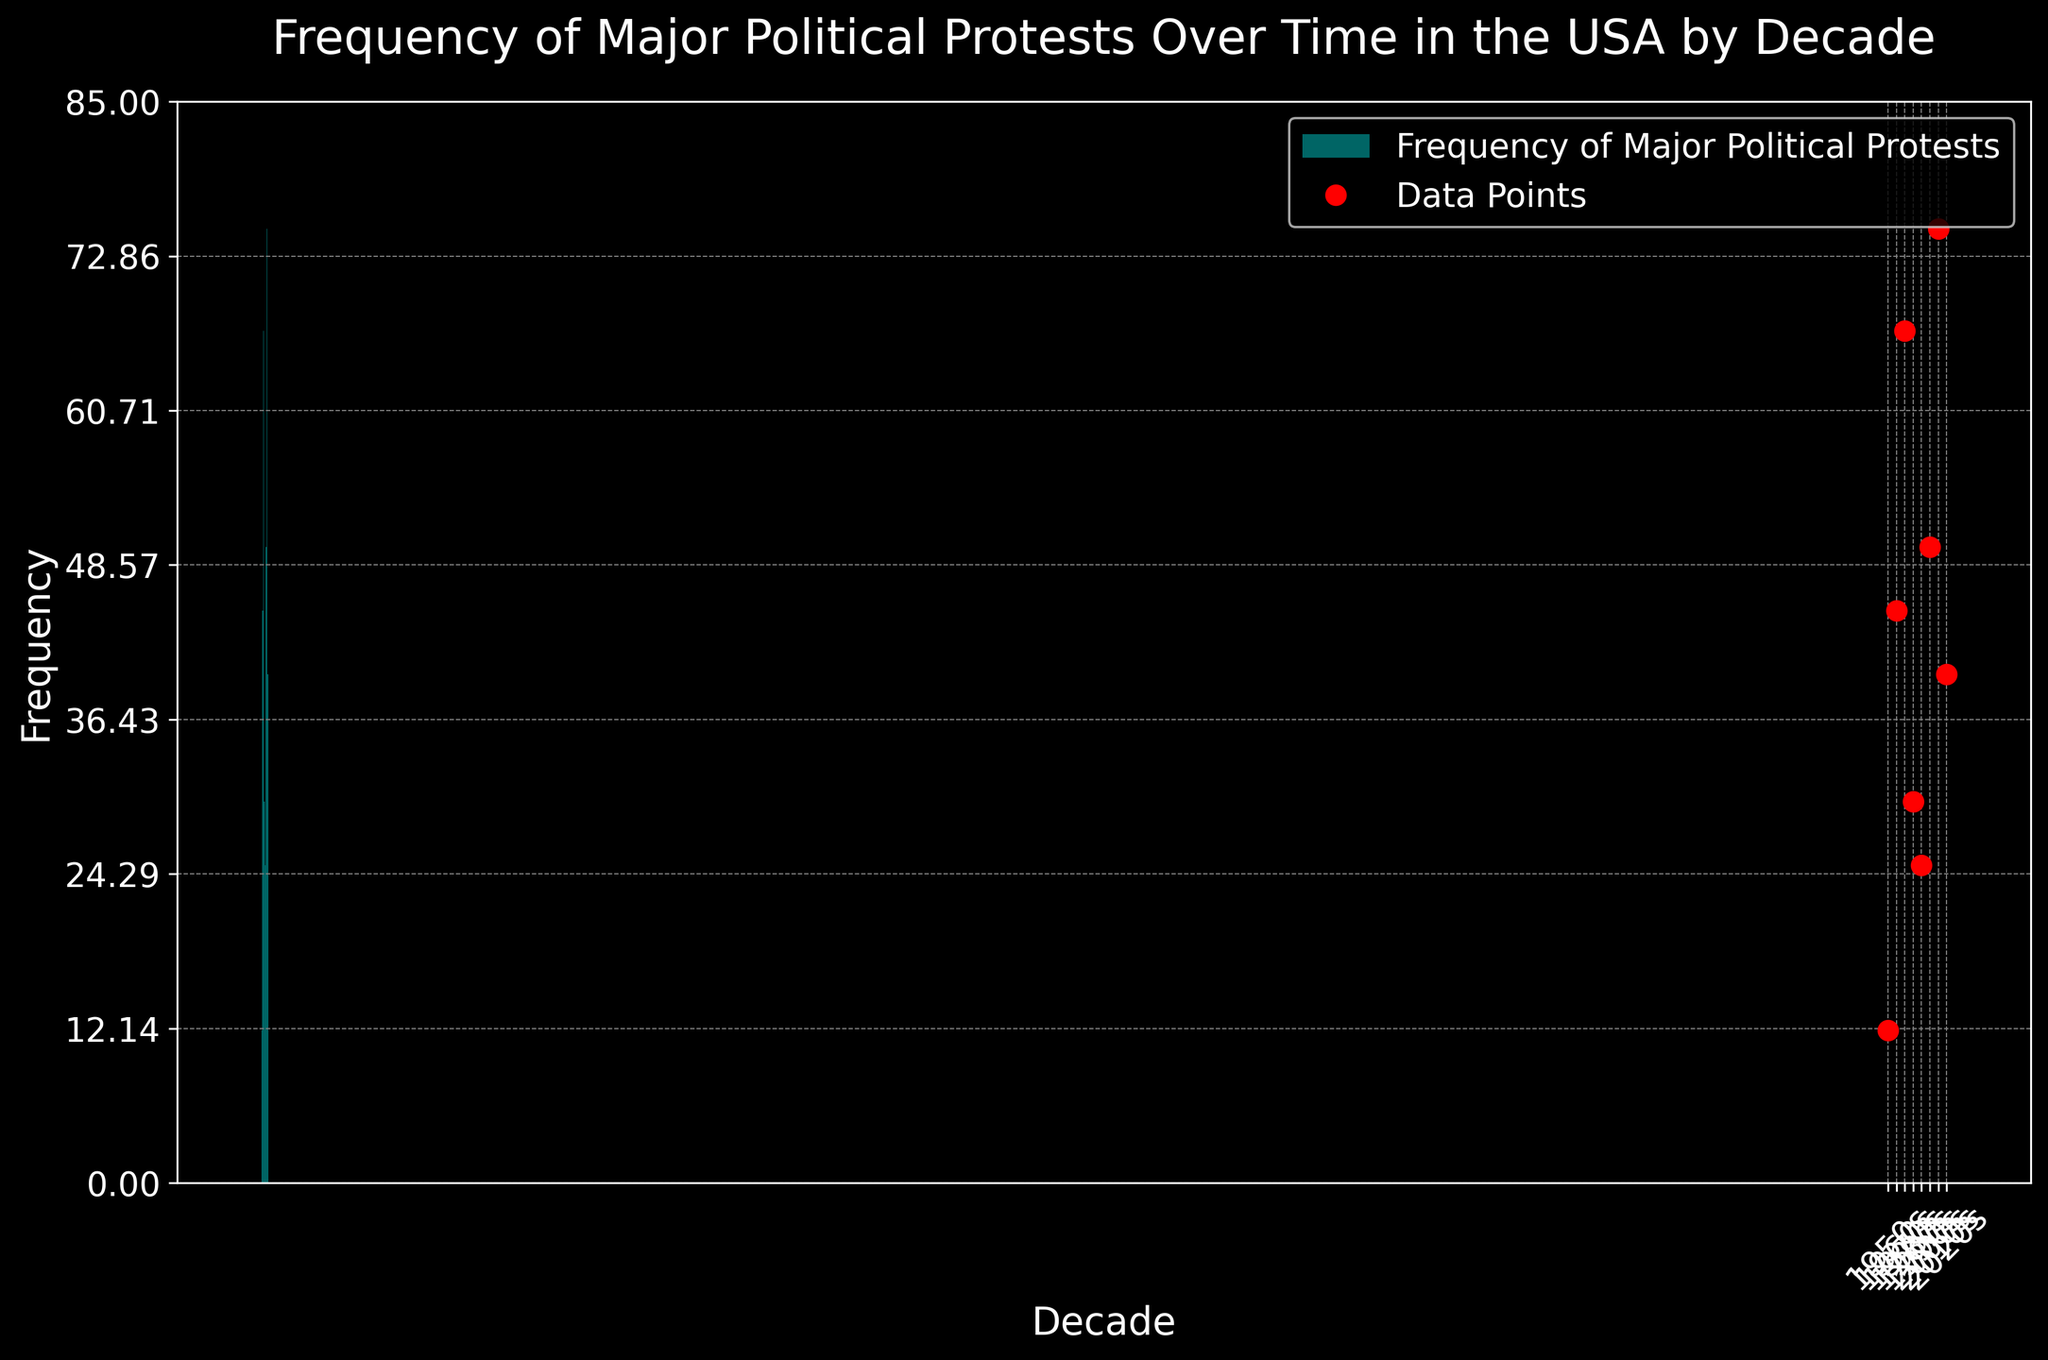How much did the frequency of major political protests increase from the 1950s to the 1960s? The frequency increased from 12 in the 1950s to 45 in the 1960s, so the increase is calculated as 45 - 12.
Answer: 33 What is the decade with the highest frequency of major political protests? By examining the heights of the stairs, the 2010s have the highest frequency, which is 75.
Answer: 2010s How does the frequency of protests in the 2020s compare to the 2000s? The frequency in the 2020s is 40, while in the 2000s it is 50. Since 40 is less than 50, the frequency decreased.
Answer: Decreased What is the average frequency of major political protests for the entire period shown? The frequencies are 12, 45, 67, 30, 25, 50, 75, and 40. The sum is 344, and there are 8 decades. The average is 344 / 8.
Answer: 43 Between which two consecutive decades is the largest increase in the frequency of major political protests observed? The increase between 1960s (45) and 1970s (67) is 22, which is larger than the increases between other consecutive decades.
Answer: 1960s to 1970s During which decade did the frequency of major political protests experience the largest decrease? The largest decrease is from the 1970s (67) to the 1980s (30), which is a drop of 37.
Answer: 1970s to 1980s What is the median frequency of major political protests across the decades? Ordering the frequencies: 12, 25, 30, 40, 45, 50, 67, 75. The median is the average of the 4th and 5th values: (40 + 45) / 2.
Answer: 42.5 How many decades had a protest frequency greater than 40? Decades with frequencies greater than 40 are: 1960s (45), 1970s (67), 2000s (50), and 2010s (75).
Answer: 4 In which decade did the frequency of major political protests fall just below half a hundred? The frequency fell just below 50 in the 1960s (45).
Answer: 1960s 